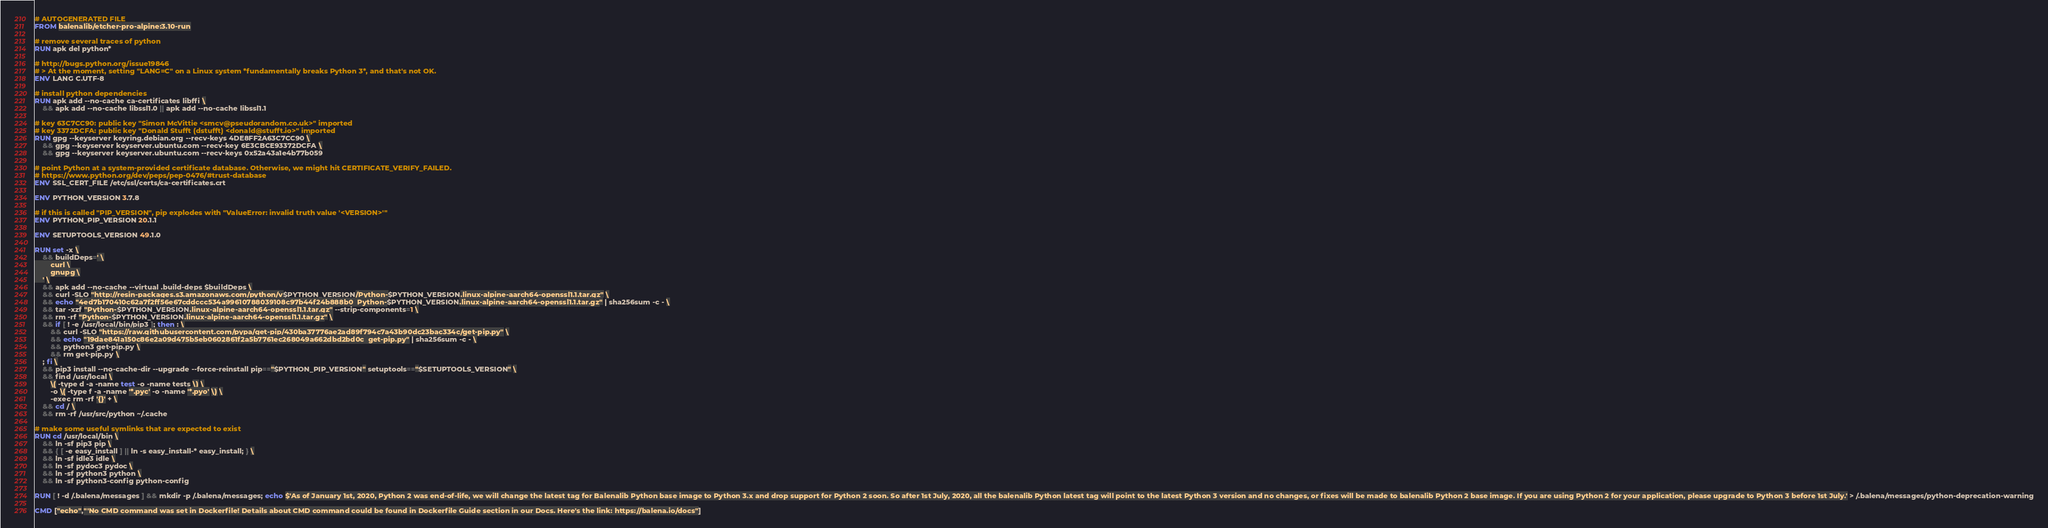<code> <loc_0><loc_0><loc_500><loc_500><_Dockerfile_># AUTOGENERATED FILE
FROM balenalib/etcher-pro-alpine:3.10-run

# remove several traces of python
RUN apk del python*

# http://bugs.python.org/issue19846
# > At the moment, setting "LANG=C" on a Linux system *fundamentally breaks Python 3*, and that's not OK.
ENV LANG C.UTF-8

# install python dependencies
RUN apk add --no-cache ca-certificates libffi \
	&& apk add --no-cache libssl1.0 || apk add --no-cache libssl1.1

# key 63C7CC90: public key "Simon McVittie <smcv@pseudorandom.co.uk>" imported
# key 3372DCFA: public key "Donald Stufft (dstufft) <donald@stufft.io>" imported
RUN gpg --keyserver keyring.debian.org --recv-keys 4DE8FF2A63C7CC90 \
	&& gpg --keyserver keyserver.ubuntu.com --recv-key 6E3CBCE93372DCFA \
	&& gpg --keyserver keyserver.ubuntu.com --recv-keys 0x52a43a1e4b77b059

# point Python at a system-provided certificate database. Otherwise, we might hit CERTIFICATE_VERIFY_FAILED.
# https://www.python.org/dev/peps/pep-0476/#trust-database
ENV SSL_CERT_FILE /etc/ssl/certs/ca-certificates.crt

ENV PYTHON_VERSION 3.7.8

# if this is called "PIP_VERSION", pip explodes with "ValueError: invalid truth value '<VERSION>'"
ENV PYTHON_PIP_VERSION 20.1.1

ENV SETUPTOOLS_VERSION 49.1.0

RUN set -x \
	&& buildDeps=' \
		curl \
		gnupg \
	' \
	&& apk add --no-cache --virtual .build-deps $buildDeps \
	&& curl -SLO "http://resin-packages.s3.amazonaws.com/python/v$PYTHON_VERSION/Python-$PYTHON_VERSION.linux-alpine-aarch64-openssl1.1.tar.gz" \
	&& echo "4ed7b170410c62a7f2ff56e67cddccc534a99610788039108c97b44f24b888b0  Python-$PYTHON_VERSION.linux-alpine-aarch64-openssl1.1.tar.gz" | sha256sum -c - \
	&& tar -xzf "Python-$PYTHON_VERSION.linux-alpine-aarch64-openssl1.1.tar.gz" --strip-components=1 \
	&& rm -rf "Python-$PYTHON_VERSION.linux-alpine-aarch64-openssl1.1.tar.gz" \
	&& if [ ! -e /usr/local/bin/pip3 ]; then : \
		&& curl -SLO "https://raw.githubusercontent.com/pypa/get-pip/430ba37776ae2ad89f794c7a43b90dc23bac334c/get-pip.py" \
		&& echo "19dae841a150c86e2a09d475b5eb0602861f2a5b7761ec268049a662dbd2bd0c  get-pip.py" | sha256sum -c - \
		&& python3 get-pip.py \
		&& rm get-pip.py \
	; fi \
	&& pip3 install --no-cache-dir --upgrade --force-reinstall pip=="$PYTHON_PIP_VERSION" setuptools=="$SETUPTOOLS_VERSION" \
	&& find /usr/local \
		\( -type d -a -name test -o -name tests \) \
		-o \( -type f -a -name '*.pyc' -o -name '*.pyo' \) \
		-exec rm -rf '{}' + \
	&& cd / \
	&& rm -rf /usr/src/python ~/.cache

# make some useful symlinks that are expected to exist
RUN cd /usr/local/bin \
	&& ln -sf pip3 pip \
	&& { [ -e easy_install ] || ln -s easy_install-* easy_install; } \
	&& ln -sf idle3 idle \
	&& ln -sf pydoc3 pydoc \
	&& ln -sf python3 python \
	&& ln -sf python3-config python-config

RUN [ ! -d /.balena/messages ] && mkdir -p /.balena/messages; echo $'As of January 1st, 2020, Python 2 was end-of-life, we will change the latest tag for Balenalib Python base image to Python 3.x and drop support for Python 2 soon. So after 1st July, 2020, all the balenalib Python latest tag will point to the latest Python 3 version and no changes, or fixes will be made to balenalib Python 2 base image. If you are using Python 2 for your application, please upgrade to Python 3 before 1st July.' > /.balena/messages/python-deprecation-warning

CMD ["echo","'No CMD command was set in Dockerfile! Details about CMD command could be found in Dockerfile Guide section in our Docs. Here's the link: https://balena.io/docs"]
</code> 